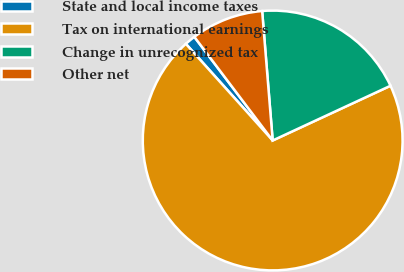Convert chart to OTSL. <chart><loc_0><loc_0><loc_500><loc_500><pie_chart><fcel>State and local income taxes<fcel>Tax on international earnings<fcel>Change in unrecognized tax<fcel>Other net<nl><fcel>1.35%<fcel>70.27%<fcel>19.37%<fcel>9.01%<nl></chart> 